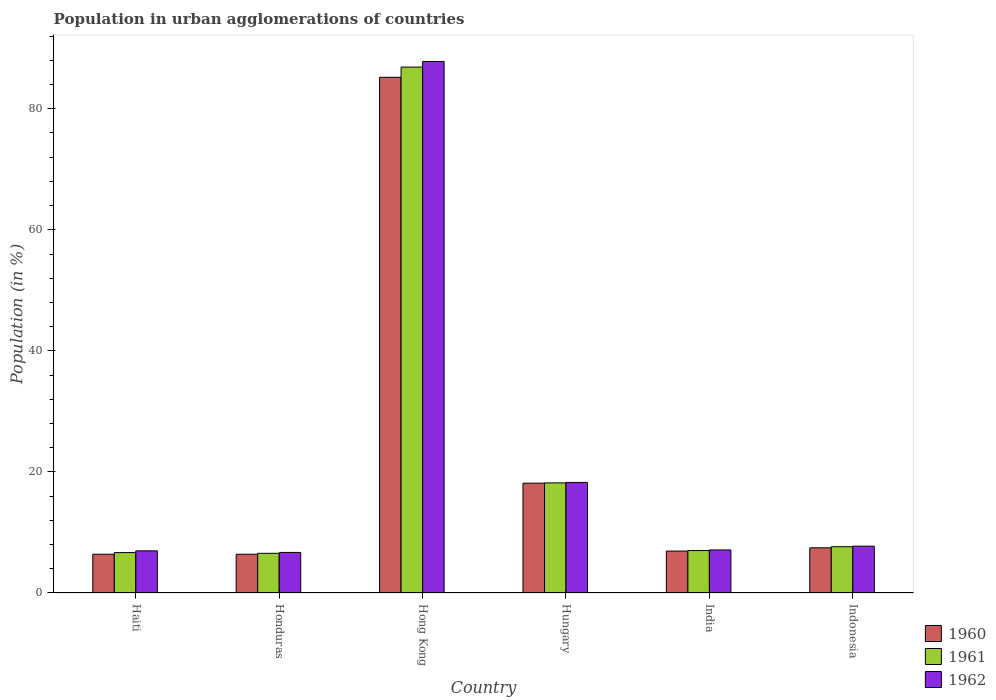How many different coloured bars are there?
Provide a succinct answer. 3. How many groups of bars are there?
Your response must be concise. 6. How many bars are there on the 2nd tick from the left?
Provide a short and direct response. 3. In how many cases, is the number of bars for a given country not equal to the number of legend labels?
Your answer should be very brief. 0. What is the percentage of population in urban agglomerations in 1960 in Indonesia?
Your answer should be very brief. 7.46. Across all countries, what is the maximum percentage of population in urban agglomerations in 1961?
Give a very brief answer. 86.89. Across all countries, what is the minimum percentage of population in urban agglomerations in 1961?
Provide a short and direct response. 6.55. In which country was the percentage of population in urban agglomerations in 1960 maximum?
Make the answer very short. Hong Kong. In which country was the percentage of population in urban agglomerations in 1961 minimum?
Provide a short and direct response. Honduras. What is the total percentage of population in urban agglomerations in 1961 in the graph?
Ensure brevity in your answer.  132.97. What is the difference between the percentage of population in urban agglomerations in 1960 in Honduras and that in Hong Kong?
Keep it short and to the point. -78.8. What is the difference between the percentage of population in urban agglomerations in 1961 in India and the percentage of population in urban agglomerations in 1962 in Honduras?
Offer a terse response. 0.31. What is the average percentage of population in urban agglomerations in 1960 per country?
Provide a short and direct response. 21.76. What is the difference between the percentage of population in urban agglomerations of/in 1962 and percentage of population in urban agglomerations of/in 1960 in India?
Provide a succinct answer. 0.19. What is the ratio of the percentage of population in urban agglomerations in 1961 in Haiti to that in Honduras?
Your response must be concise. 1.02. Is the difference between the percentage of population in urban agglomerations in 1962 in Honduras and Hong Kong greater than the difference between the percentage of population in urban agglomerations in 1960 in Honduras and Hong Kong?
Provide a succinct answer. No. What is the difference between the highest and the second highest percentage of population in urban agglomerations in 1960?
Your answer should be compact. -67.06. What is the difference between the highest and the lowest percentage of population in urban agglomerations in 1960?
Give a very brief answer. 78.8. In how many countries, is the percentage of population in urban agglomerations in 1962 greater than the average percentage of population in urban agglomerations in 1962 taken over all countries?
Provide a short and direct response. 1. Is it the case that in every country, the sum of the percentage of population in urban agglomerations in 1960 and percentage of population in urban agglomerations in 1961 is greater than the percentage of population in urban agglomerations in 1962?
Provide a succinct answer. Yes. What is the difference between two consecutive major ticks on the Y-axis?
Make the answer very short. 20. Does the graph contain grids?
Provide a succinct answer. No. How are the legend labels stacked?
Keep it short and to the point. Vertical. What is the title of the graph?
Keep it short and to the point. Population in urban agglomerations of countries. Does "1983" appear as one of the legend labels in the graph?
Offer a very short reply. No. What is the Population (in %) of 1960 in Haiti?
Your answer should be compact. 6.4. What is the Population (in %) in 1961 in Haiti?
Give a very brief answer. 6.68. What is the Population (in %) of 1962 in Haiti?
Make the answer very short. 6.96. What is the Population (in %) in 1960 in Honduras?
Your answer should be very brief. 6.4. What is the Population (in %) of 1961 in Honduras?
Keep it short and to the point. 6.55. What is the Population (in %) of 1962 in Honduras?
Offer a terse response. 6.7. What is the Population (in %) of 1960 in Hong Kong?
Keep it short and to the point. 85.2. What is the Population (in %) in 1961 in Hong Kong?
Provide a short and direct response. 86.89. What is the Population (in %) of 1962 in Hong Kong?
Your answer should be compact. 87.82. What is the Population (in %) in 1960 in Hungary?
Your answer should be compact. 18.14. What is the Population (in %) of 1961 in Hungary?
Provide a short and direct response. 18.19. What is the Population (in %) in 1962 in Hungary?
Make the answer very short. 18.26. What is the Population (in %) of 1960 in India?
Keep it short and to the point. 6.93. What is the Population (in %) of 1961 in India?
Offer a very short reply. 7.01. What is the Population (in %) of 1962 in India?
Provide a short and direct response. 7.11. What is the Population (in %) of 1960 in Indonesia?
Offer a terse response. 7.46. What is the Population (in %) in 1961 in Indonesia?
Give a very brief answer. 7.65. What is the Population (in %) of 1962 in Indonesia?
Offer a terse response. 7.73. Across all countries, what is the maximum Population (in %) of 1960?
Keep it short and to the point. 85.2. Across all countries, what is the maximum Population (in %) of 1961?
Your answer should be compact. 86.89. Across all countries, what is the maximum Population (in %) of 1962?
Give a very brief answer. 87.82. Across all countries, what is the minimum Population (in %) of 1960?
Provide a succinct answer. 6.4. Across all countries, what is the minimum Population (in %) in 1961?
Provide a short and direct response. 6.55. Across all countries, what is the minimum Population (in %) of 1962?
Provide a succinct answer. 6.7. What is the total Population (in %) in 1960 in the graph?
Make the answer very short. 130.54. What is the total Population (in %) in 1961 in the graph?
Your response must be concise. 132.97. What is the total Population (in %) in 1962 in the graph?
Ensure brevity in your answer.  134.59. What is the difference between the Population (in %) of 1960 in Haiti and that in Honduras?
Your answer should be very brief. 0. What is the difference between the Population (in %) in 1961 in Haiti and that in Honduras?
Ensure brevity in your answer.  0.12. What is the difference between the Population (in %) of 1962 in Haiti and that in Honduras?
Keep it short and to the point. 0.26. What is the difference between the Population (in %) in 1960 in Haiti and that in Hong Kong?
Give a very brief answer. -78.8. What is the difference between the Population (in %) in 1961 in Haiti and that in Hong Kong?
Provide a succinct answer. -80.21. What is the difference between the Population (in %) of 1962 in Haiti and that in Hong Kong?
Make the answer very short. -80.86. What is the difference between the Population (in %) in 1960 in Haiti and that in Hungary?
Your answer should be very brief. -11.74. What is the difference between the Population (in %) of 1961 in Haiti and that in Hungary?
Your response must be concise. -11.51. What is the difference between the Population (in %) of 1962 in Haiti and that in Hungary?
Your answer should be compact. -11.3. What is the difference between the Population (in %) in 1960 in Haiti and that in India?
Ensure brevity in your answer.  -0.52. What is the difference between the Population (in %) of 1961 in Haiti and that in India?
Make the answer very short. -0.34. What is the difference between the Population (in %) in 1962 in Haiti and that in India?
Offer a very short reply. -0.15. What is the difference between the Population (in %) of 1960 in Haiti and that in Indonesia?
Your answer should be compact. -1.06. What is the difference between the Population (in %) in 1961 in Haiti and that in Indonesia?
Provide a short and direct response. -0.97. What is the difference between the Population (in %) in 1962 in Haiti and that in Indonesia?
Give a very brief answer. -0.77. What is the difference between the Population (in %) of 1960 in Honduras and that in Hong Kong?
Provide a succinct answer. -78.8. What is the difference between the Population (in %) of 1961 in Honduras and that in Hong Kong?
Make the answer very short. -80.34. What is the difference between the Population (in %) in 1962 in Honduras and that in Hong Kong?
Offer a terse response. -81.12. What is the difference between the Population (in %) of 1960 in Honduras and that in Hungary?
Your answer should be compact. -11.74. What is the difference between the Population (in %) in 1961 in Honduras and that in Hungary?
Your answer should be very brief. -11.64. What is the difference between the Population (in %) of 1962 in Honduras and that in Hungary?
Offer a very short reply. -11.56. What is the difference between the Population (in %) of 1960 in Honduras and that in India?
Keep it short and to the point. -0.53. What is the difference between the Population (in %) in 1961 in Honduras and that in India?
Provide a succinct answer. -0.46. What is the difference between the Population (in %) in 1962 in Honduras and that in India?
Your answer should be compact. -0.41. What is the difference between the Population (in %) of 1960 in Honduras and that in Indonesia?
Keep it short and to the point. -1.06. What is the difference between the Population (in %) in 1961 in Honduras and that in Indonesia?
Your answer should be very brief. -1.09. What is the difference between the Population (in %) of 1962 in Honduras and that in Indonesia?
Make the answer very short. -1.03. What is the difference between the Population (in %) in 1960 in Hong Kong and that in Hungary?
Provide a succinct answer. 67.06. What is the difference between the Population (in %) of 1961 in Hong Kong and that in Hungary?
Give a very brief answer. 68.7. What is the difference between the Population (in %) in 1962 in Hong Kong and that in Hungary?
Your response must be concise. 69.56. What is the difference between the Population (in %) in 1960 in Hong Kong and that in India?
Make the answer very short. 78.28. What is the difference between the Population (in %) of 1961 in Hong Kong and that in India?
Offer a terse response. 79.88. What is the difference between the Population (in %) of 1962 in Hong Kong and that in India?
Ensure brevity in your answer.  80.71. What is the difference between the Population (in %) in 1960 in Hong Kong and that in Indonesia?
Offer a terse response. 77.74. What is the difference between the Population (in %) of 1961 in Hong Kong and that in Indonesia?
Give a very brief answer. 79.24. What is the difference between the Population (in %) in 1962 in Hong Kong and that in Indonesia?
Your response must be concise. 80.09. What is the difference between the Population (in %) in 1960 in Hungary and that in India?
Give a very brief answer. 11.21. What is the difference between the Population (in %) in 1961 in Hungary and that in India?
Make the answer very short. 11.17. What is the difference between the Population (in %) of 1962 in Hungary and that in India?
Ensure brevity in your answer.  11.15. What is the difference between the Population (in %) of 1960 in Hungary and that in Indonesia?
Your answer should be compact. 10.68. What is the difference between the Population (in %) in 1961 in Hungary and that in Indonesia?
Provide a short and direct response. 10.54. What is the difference between the Population (in %) of 1962 in Hungary and that in Indonesia?
Make the answer very short. 10.53. What is the difference between the Population (in %) in 1960 in India and that in Indonesia?
Ensure brevity in your answer.  -0.54. What is the difference between the Population (in %) of 1961 in India and that in Indonesia?
Provide a succinct answer. -0.63. What is the difference between the Population (in %) of 1962 in India and that in Indonesia?
Keep it short and to the point. -0.62. What is the difference between the Population (in %) in 1960 in Haiti and the Population (in %) in 1961 in Honduras?
Give a very brief answer. -0.15. What is the difference between the Population (in %) of 1960 in Haiti and the Population (in %) of 1962 in Honduras?
Your answer should be compact. -0.3. What is the difference between the Population (in %) in 1961 in Haiti and the Population (in %) in 1962 in Honduras?
Give a very brief answer. -0.02. What is the difference between the Population (in %) in 1960 in Haiti and the Population (in %) in 1961 in Hong Kong?
Make the answer very short. -80.49. What is the difference between the Population (in %) in 1960 in Haiti and the Population (in %) in 1962 in Hong Kong?
Give a very brief answer. -81.42. What is the difference between the Population (in %) in 1961 in Haiti and the Population (in %) in 1962 in Hong Kong?
Give a very brief answer. -81.14. What is the difference between the Population (in %) in 1960 in Haiti and the Population (in %) in 1961 in Hungary?
Provide a short and direct response. -11.79. What is the difference between the Population (in %) of 1960 in Haiti and the Population (in %) of 1962 in Hungary?
Offer a very short reply. -11.86. What is the difference between the Population (in %) of 1961 in Haiti and the Population (in %) of 1962 in Hungary?
Make the answer very short. -11.59. What is the difference between the Population (in %) in 1960 in Haiti and the Population (in %) in 1961 in India?
Give a very brief answer. -0.61. What is the difference between the Population (in %) in 1960 in Haiti and the Population (in %) in 1962 in India?
Provide a short and direct response. -0.71. What is the difference between the Population (in %) of 1961 in Haiti and the Population (in %) of 1962 in India?
Your answer should be compact. -0.43. What is the difference between the Population (in %) in 1960 in Haiti and the Population (in %) in 1961 in Indonesia?
Give a very brief answer. -1.24. What is the difference between the Population (in %) of 1960 in Haiti and the Population (in %) of 1962 in Indonesia?
Provide a short and direct response. -1.33. What is the difference between the Population (in %) in 1961 in Haiti and the Population (in %) in 1962 in Indonesia?
Ensure brevity in your answer.  -1.06. What is the difference between the Population (in %) in 1960 in Honduras and the Population (in %) in 1961 in Hong Kong?
Your answer should be very brief. -80.49. What is the difference between the Population (in %) of 1960 in Honduras and the Population (in %) of 1962 in Hong Kong?
Offer a terse response. -81.42. What is the difference between the Population (in %) in 1961 in Honduras and the Population (in %) in 1962 in Hong Kong?
Offer a very short reply. -81.27. What is the difference between the Population (in %) in 1960 in Honduras and the Population (in %) in 1961 in Hungary?
Give a very brief answer. -11.79. What is the difference between the Population (in %) of 1960 in Honduras and the Population (in %) of 1962 in Hungary?
Offer a very short reply. -11.86. What is the difference between the Population (in %) in 1961 in Honduras and the Population (in %) in 1962 in Hungary?
Offer a terse response. -11.71. What is the difference between the Population (in %) in 1960 in Honduras and the Population (in %) in 1961 in India?
Your answer should be very brief. -0.61. What is the difference between the Population (in %) in 1960 in Honduras and the Population (in %) in 1962 in India?
Your response must be concise. -0.71. What is the difference between the Population (in %) of 1961 in Honduras and the Population (in %) of 1962 in India?
Keep it short and to the point. -0.56. What is the difference between the Population (in %) of 1960 in Honduras and the Population (in %) of 1961 in Indonesia?
Make the answer very short. -1.24. What is the difference between the Population (in %) of 1960 in Honduras and the Population (in %) of 1962 in Indonesia?
Provide a short and direct response. -1.33. What is the difference between the Population (in %) of 1961 in Honduras and the Population (in %) of 1962 in Indonesia?
Your response must be concise. -1.18. What is the difference between the Population (in %) in 1960 in Hong Kong and the Population (in %) in 1961 in Hungary?
Provide a short and direct response. 67.01. What is the difference between the Population (in %) of 1960 in Hong Kong and the Population (in %) of 1962 in Hungary?
Your response must be concise. 66.94. What is the difference between the Population (in %) of 1961 in Hong Kong and the Population (in %) of 1962 in Hungary?
Provide a succinct answer. 68.63. What is the difference between the Population (in %) in 1960 in Hong Kong and the Population (in %) in 1961 in India?
Your answer should be very brief. 78.19. What is the difference between the Population (in %) of 1960 in Hong Kong and the Population (in %) of 1962 in India?
Give a very brief answer. 78.09. What is the difference between the Population (in %) of 1961 in Hong Kong and the Population (in %) of 1962 in India?
Your response must be concise. 79.78. What is the difference between the Population (in %) of 1960 in Hong Kong and the Population (in %) of 1961 in Indonesia?
Your response must be concise. 77.56. What is the difference between the Population (in %) in 1960 in Hong Kong and the Population (in %) in 1962 in Indonesia?
Keep it short and to the point. 77.47. What is the difference between the Population (in %) of 1961 in Hong Kong and the Population (in %) of 1962 in Indonesia?
Give a very brief answer. 79.16. What is the difference between the Population (in %) in 1960 in Hungary and the Population (in %) in 1961 in India?
Offer a very short reply. 11.13. What is the difference between the Population (in %) of 1960 in Hungary and the Population (in %) of 1962 in India?
Your answer should be compact. 11.03. What is the difference between the Population (in %) of 1961 in Hungary and the Population (in %) of 1962 in India?
Offer a terse response. 11.08. What is the difference between the Population (in %) in 1960 in Hungary and the Population (in %) in 1961 in Indonesia?
Your answer should be compact. 10.49. What is the difference between the Population (in %) of 1960 in Hungary and the Population (in %) of 1962 in Indonesia?
Give a very brief answer. 10.41. What is the difference between the Population (in %) of 1961 in Hungary and the Population (in %) of 1962 in Indonesia?
Give a very brief answer. 10.46. What is the difference between the Population (in %) of 1960 in India and the Population (in %) of 1961 in Indonesia?
Give a very brief answer. -0.72. What is the difference between the Population (in %) in 1960 in India and the Population (in %) in 1962 in Indonesia?
Offer a terse response. -0.81. What is the difference between the Population (in %) of 1961 in India and the Population (in %) of 1962 in Indonesia?
Your answer should be very brief. -0.72. What is the average Population (in %) in 1960 per country?
Keep it short and to the point. 21.76. What is the average Population (in %) of 1961 per country?
Make the answer very short. 22.16. What is the average Population (in %) in 1962 per country?
Ensure brevity in your answer.  22.43. What is the difference between the Population (in %) in 1960 and Population (in %) in 1961 in Haiti?
Offer a very short reply. -0.27. What is the difference between the Population (in %) in 1960 and Population (in %) in 1962 in Haiti?
Give a very brief answer. -0.56. What is the difference between the Population (in %) of 1961 and Population (in %) of 1962 in Haiti?
Keep it short and to the point. -0.29. What is the difference between the Population (in %) of 1960 and Population (in %) of 1961 in Honduras?
Offer a very short reply. -0.15. What is the difference between the Population (in %) of 1960 and Population (in %) of 1962 in Honduras?
Your answer should be very brief. -0.3. What is the difference between the Population (in %) in 1961 and Population (in %) in 1962 in Honduras?
Your answer should be compact. -0.15. What is the difference between the Population (in %) of 1960 and Population (in %) of 1961 in Hong Kong?
Keep it short and to the point. -1.69. What is the difference between the Population (in %) of 1960 and Population (in %) of 1962 in Hong Kong?
Ensure brevity in your answer.  -2.62. What is the difference between the Population (in %) in 1961 and Population (in %) in 1962 in Hong Kong?
Offer a very short reply. -0.93. What is the difference between the Population (in %) of 1960 and Population (in %) of 1961 in Hungary?
Offer a terse response. -0.05. What is the difference between the Population (in %) in 1960 and Population (in %) in 1962 in Hungary?
Make the answer very short. -0.12. What is the difference between the Population (in %) in 1961 and Population (in %) in 1962 in Hungary?
Provide a succinct answer. -0.07. What is the difference between the Population (in %) of 1960 and Population (in %) of 1961 in India?
Give a very brief answer. -0.09. What is the difference between the Population (in %) in 1960 and Population (in %) in 1962 in India?
Give a very brief answer. -0.19. What is the difference between the Population (in %) in 1961 and Population (in %) in 1962 in India?
Your answer should be very brief. -0.1. What is the difference between the Population (in %) of 1960 and Population (in %) of 1961 in Indonesia?
Give a very brief answer. -0.18. What is the difference between the Population (in %) in 1960 and Population (in %) in 1962 in Indonesia?
Provide a short and direct response. -0.27. What is the difference between the Population (in %) in 1961 and Population (in %) in 1962 in Indonesia?
Keep it short and to the point. -0.09. What is the ratio of the Population (in %) in 1961 in Haiti to that in Honduras?
Keep it short and to the point. 1.02. What is the ratio of the Population (in %) in 1962 in Haiti to that in Honduras?
Your answer should be compact. 1.04. What is the ratio of the Population (in %) in 1960 in Haiti to that in Hong Kong?
Your answer should be compact. 0.08. What is the ratio of the Population (in %) of 1961 in Haiti to that in Hong Kong?
Keep it short and to the point. 0.08. What is the ratio of the Population (in %) in 1962 in Haiti to that in Hong Kong?
Provide a succinct answer. 0.08. What is the ratio of the Population (in %) in 1960 in Haiti to that in Hungary?
Offer a terse response. 0.35. What is the ratio of the Population (in %) in 1961 in Haiti to that in Hungary?
Your answer should be very brief. 0.37. What is the ratio of the Population (in %) of 1962 in Haiti to that in Hungary?
Your answer should be very brief. 0.38. What is the ratio of the Population (in %) of 1960 in Haiti to that in India?
Make the answer very short. 0.92. What is the ratio of the Population (in %) of 1961 in Haiti to that in India?
Provide a succinct answer. 0.95. What is the ratio of the Population (in %) of 1962 in Haiti to that in India?
Provide a succinct answer. 0.98. What is the ratio of the Population (in %) of 1960 in Haiti to that in Indonesia?
Your answer should be compact. 0.86. What is the ratio of the Population (in %) in 1961 in Haiti to that in Indonesia?
Your answer should be compact. 0.87. What is the ratio of the Population (in %) of 1962 in Haiti to that in Indonesia?
Offer a very short reply. 0.9. What is the ratio of the Population (in %) of 1960 in Honduras to that in Hong Kong?
Make the answer very short. 0.08. What is the ratio of the Population (in %) in 1961 in Honduras to that in Hong Kong?
Your answer should be compact. 0.08. What is the ratio of the Population (in %) in 1962 in Honduras to that in Hong Kong?
Keep it short and to the point. 0.08. What is the ratio of the Population (in %) in 1960 in Honduras to that in Hungary?
Provide a short and direct response. 0.35. What is the ratio of the Population (in %) of 1961 in Honduras to that in Hungary?
Your answer should be very brief. 0.36. What is the ratio of the Population (in %) of 1962 in Honduras to that in Hungary?
Your answer should be compact. 0.37. What is the ratio of the Population (in %) of 1960 in Honduras to that in India?
Provide a short and direct response. 0.92. What is the ratio of the Population (in %) of 1961 in Honduras to that in India?
Your answer should be compact. 0.93. What is the ratio of the Population (in %) of 1962 in Honduras to that in India?
Provide a short and direct response. 0.94. What is the ratio of the Population (in %) of 1960 in Honduras to that in Indonesia?
Provide a succinct answer. 0.86. What is the ratio of the Population (in %) of 1961 in Honduras to that in Indonesia?
Provide a succinct answer. 0.86. What is the ratio of the Population (in %) in 1962 in Honduras to that in Indonesia?
Provide a succinct answer. 0.87. What is the ratio of the Population (in %) of 1960 in Hong Kong to that in Hungary?
Provide a succinct answer. 4.7. What is the ratio of the Population (in %) in 1961 in Hong Kong to that in Hungary?
Your answer should be compact. 4.78. What is the ratio of the Population (in %) in 1962 in Hong Kong to that in Hungary?
Your answer should be compact. 4.81. What is the ratio of the Population (in %) in 1960 in Hong Kong to that in India?
Ensure brevity in your answer.  12.3. What is the ratio of the Population (in %) of 1961 in Hong Kong to that in India?
Your response must be concise. 12.39. What is the ratio of the Population (in %) of 1962 in Hong Kong to that in India?
Offer a very short reply. 12.35. What is the ratio of the Population (in %) of 1960 in Hong Kong to that in Indonesia?
Give a very brief answer. 11.41. What is the ratio of the Population (in %) of 1961 in Hong Kong to that in Indonesia?
Provide a succinct answer. 11.37. What is the ratio of the Population (in %) of 1962 in Hong Kong to that in Indonesia?
Keep it short and to the point. 11.36. What is the ratio of the Population (in %) of 1960 in Hungary to that in India?
Keep it short and to the point. 2.62. What is the ratio of the Population (in %) of 1961 in Hungary to that in India?
Your answer should be very brief. 2.59. What is the ratio of the Population (in %) in 1962 in Hungary to that in India?
Provide a short and direct response. 2.57. What is the ratio of the Population (in %) in 1960 in Hungary to that in Indonesia?
Your response must be concise. 2.43. What is the ratio of the Population (in %) in 1961 in Hungary to that in Indonesia?
Provide a short and direct response. 2.38. What is the ratio of the Population (in %) of 1962 in Hungary to that in Indonesia?
Ensure brevity in your answer.  2.36. What is the ratio of the Population (in %) of 1960 in India to that in Indonesia?
Ensure brevity in your answer.  0.93. What is the ratio of the Population (in %) of 1961 in India to that in Indonesia?
Keep it short and to the point. 0.92. What is the ratio of the Population (in %) of 1962 in India to that in Indonesia?
Offer a very short reply. 0.92. What is the difference between the highest and the second highest Population (in %) of 1960?
Offer a terse response. 67.06. What is the difference between the highest and the second highest Population (in %) in 1961?
Offer a terse response. 68.7. What is the difference between the highest and the second highest Population (in %) in 1962?
Offer a very short reply. 69.56. What is the difference between the highest and the lowest Population (in %) of 1960?
Make the answer very short. 78.8. What is the difference between the highest and the lowest Population (in %) in 1961?
Provide a succinct answer. 80.34. What is the difference between the highest and the lowest Population (in %) in 1962?
Provide a short and direct response. 81.12. 